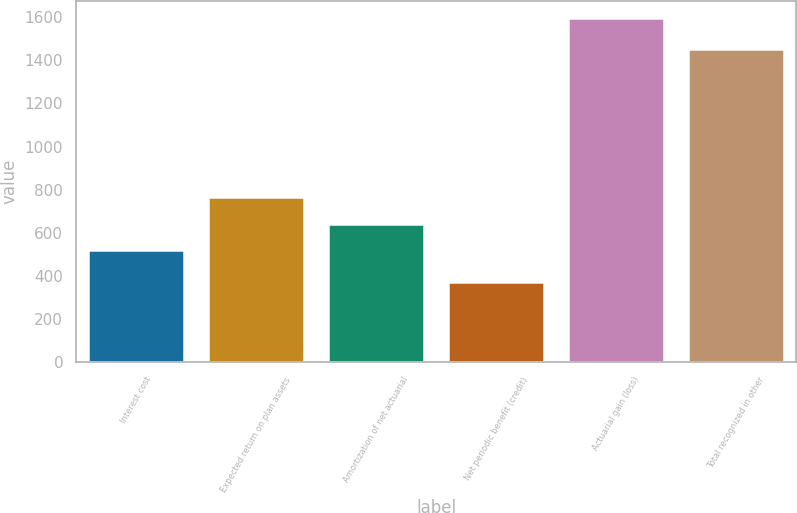<chart> <loc_0><loc_0><loc_500><loc_500><bar_chart><fcel>Interest cost<fcel>Expected return on plan assets<fcel>Amortization of net actuarial<fcel>Net periodic benefit (credit)<fcel>Actuarial gain (loss)<fcel>Total recognized in other<nl><fcel>520<fcel>765<fcel>642.5<fcel>371<fcel>1596<fcel>1450<nl></chart> 